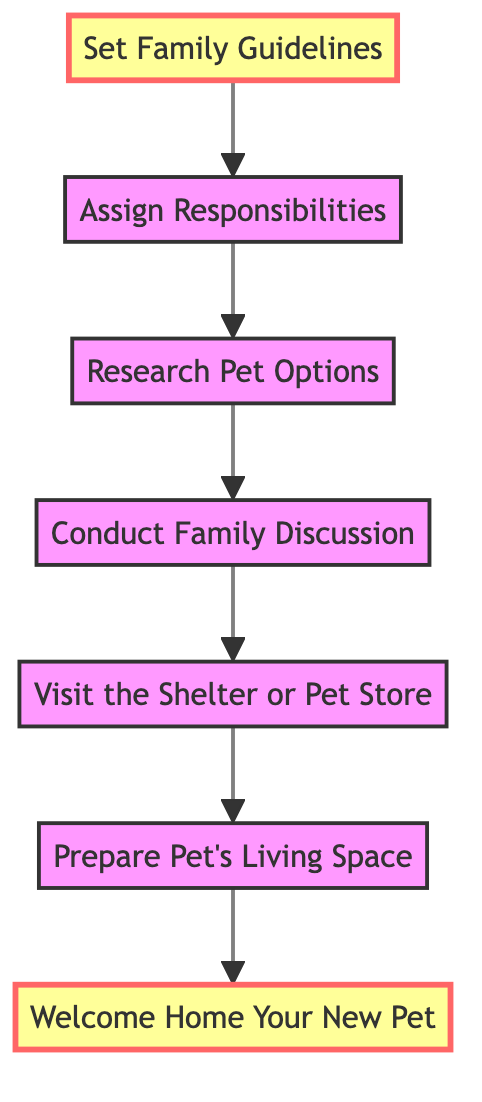What is the first step in welcoming a pet? The first step in the diagram is "Welcome Home Your New Pet," which is the initial action taken after acquiring a new pet. This step emphasizes the celebration of the pet's arrival and preparation for its care.
Answer: Welcome Home Your New Pet How many nodes are present in the diagram? By counting each distinct labeled step in the flowchart, we find there are a total of seven nodes. These nodes include all steps from welcoming the pet to setting guidelines for its care.
Answer: Seven What step comes after "Assign Responsibilities"? The next step after "Assign Responsibilities" in the flowchart is "Research Pet Options." This sequence indicates that after determining who will take care of the pet, the family should look into what types of pets are suitable for them.
Answer: Research Pet Options Which step is highlighted in the chart? The highlighted steps in the diagram are "Welcome Home Your New Pet" and "Set Family Guidelines." This highlights their importance in the overall decision-making process regarding pet care.
Answer: Welcome Home Your New Pet, Set Family Guidelines What is the relationship between "Prepare Pet's Living Space" and "Visit the Shelter or Pet Store"? The relationship depicted in the diagram shows that "Visit the Shelter or Pet Store" directly leads to "Prepare Pet's Living Space." This means that after visiting potential pets, the next logical step is to create a suitable living environment for the chosen one.
Answer: Leads to What is the purpose of conducting a family discussion? The purpose is to gather family input about the type of pet they want, ensuring everyone's opinions and concerns are considered before proceeding with other steps in the process. It is essential for reaching a collective decision.
Answer: Gather family input What are the last two steps to take according to the diagram? The last two steps in the flowchart are "Set Family Guidelines" and "Welcome Home Your New Pet." This indicates that establishing care guidelines happens before the actual welcoming of the new pet into the home.
Answer: Set Family Guidelines, Welcome Home Your New Pet What step should happen right before researching pet options? "Conduct Family Discussion" is the step that occurs right before "Research Pet Options." This emphasizes the importance of discussing family preferences and concerns prior to investigating different pet possibilities.
Answer: Conduct Family Discussion 